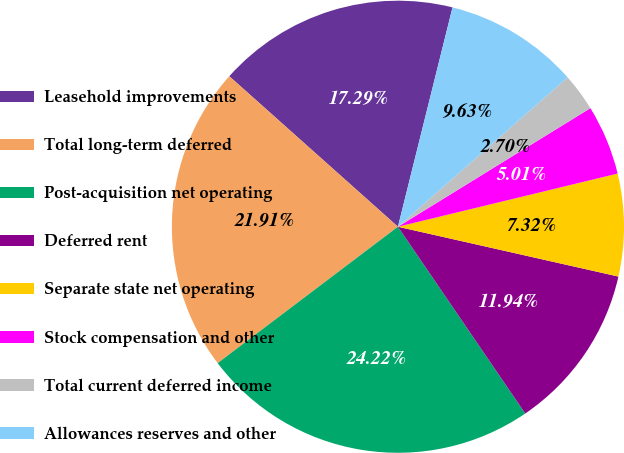<chart> <loc_0><loc_0><loc_500><loc_500><pie_chart><fcel>Leasehold improvements<fcel>Total long-term deferred<fcel>Post-acquisition net operating<fcel>Deferred rent<fcel>Separate state net operating<fcel>Stock compensation and other<fcel>Total current deferred income<fcel>Allowances reserves and other<nl><fcel>17.29%<fcel>21.91%<fcel>24.22%<fcel>11.94%<fcel>7.32%<fcel>5.01%<fcel>2.7%<fcel>9.63%<nl></chart> 